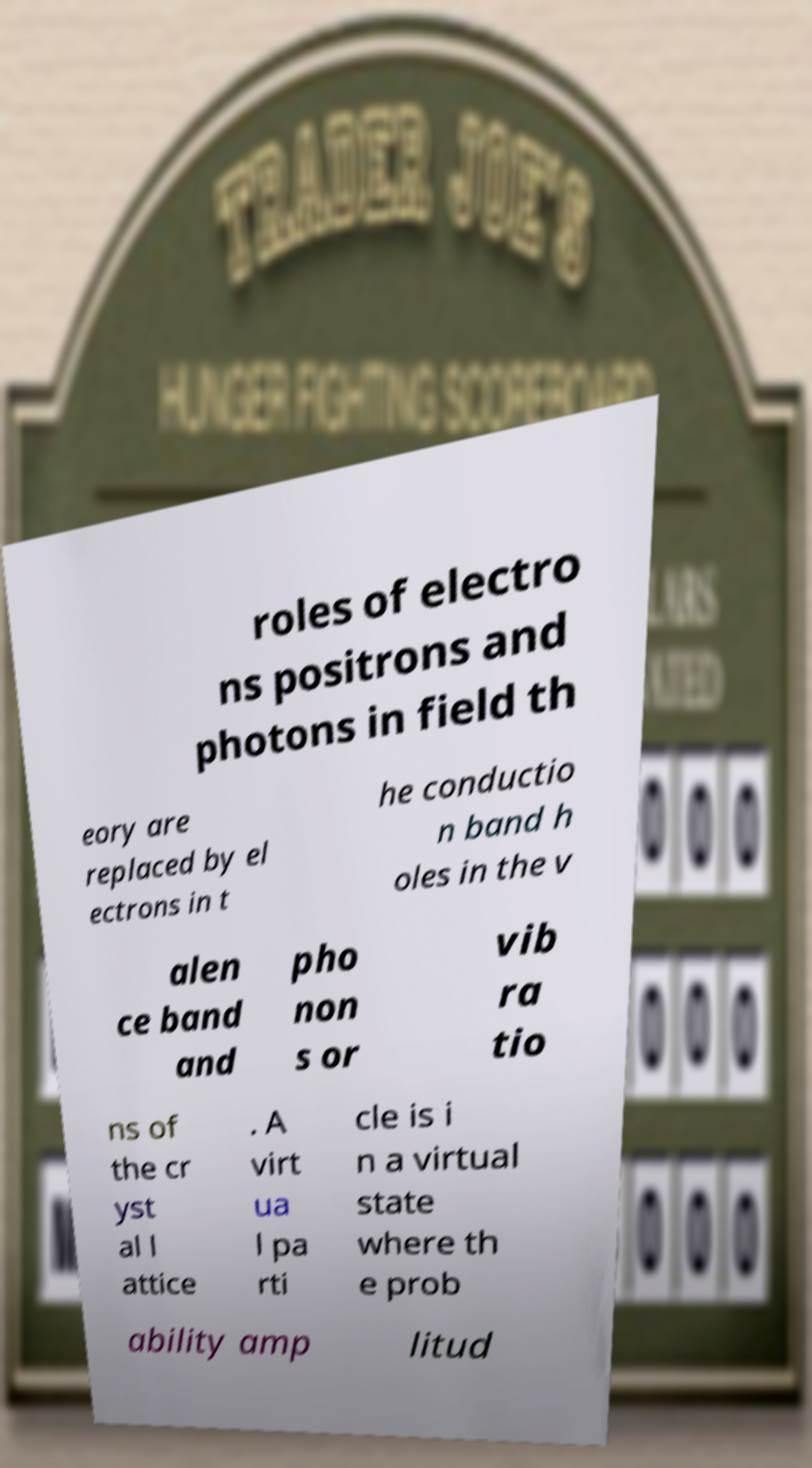Can you accurately transcribe the text from the provided image for me? roles of electro ns positrons and photons in field th eory are replaced by el ectrons in t he conductio n band h oles in the v alen ce band and pho non s or vib ra tio ns of the cr yst al l attice . A virt ua l pa rti cle is i n a virtual state where th e prob ability amp litud 